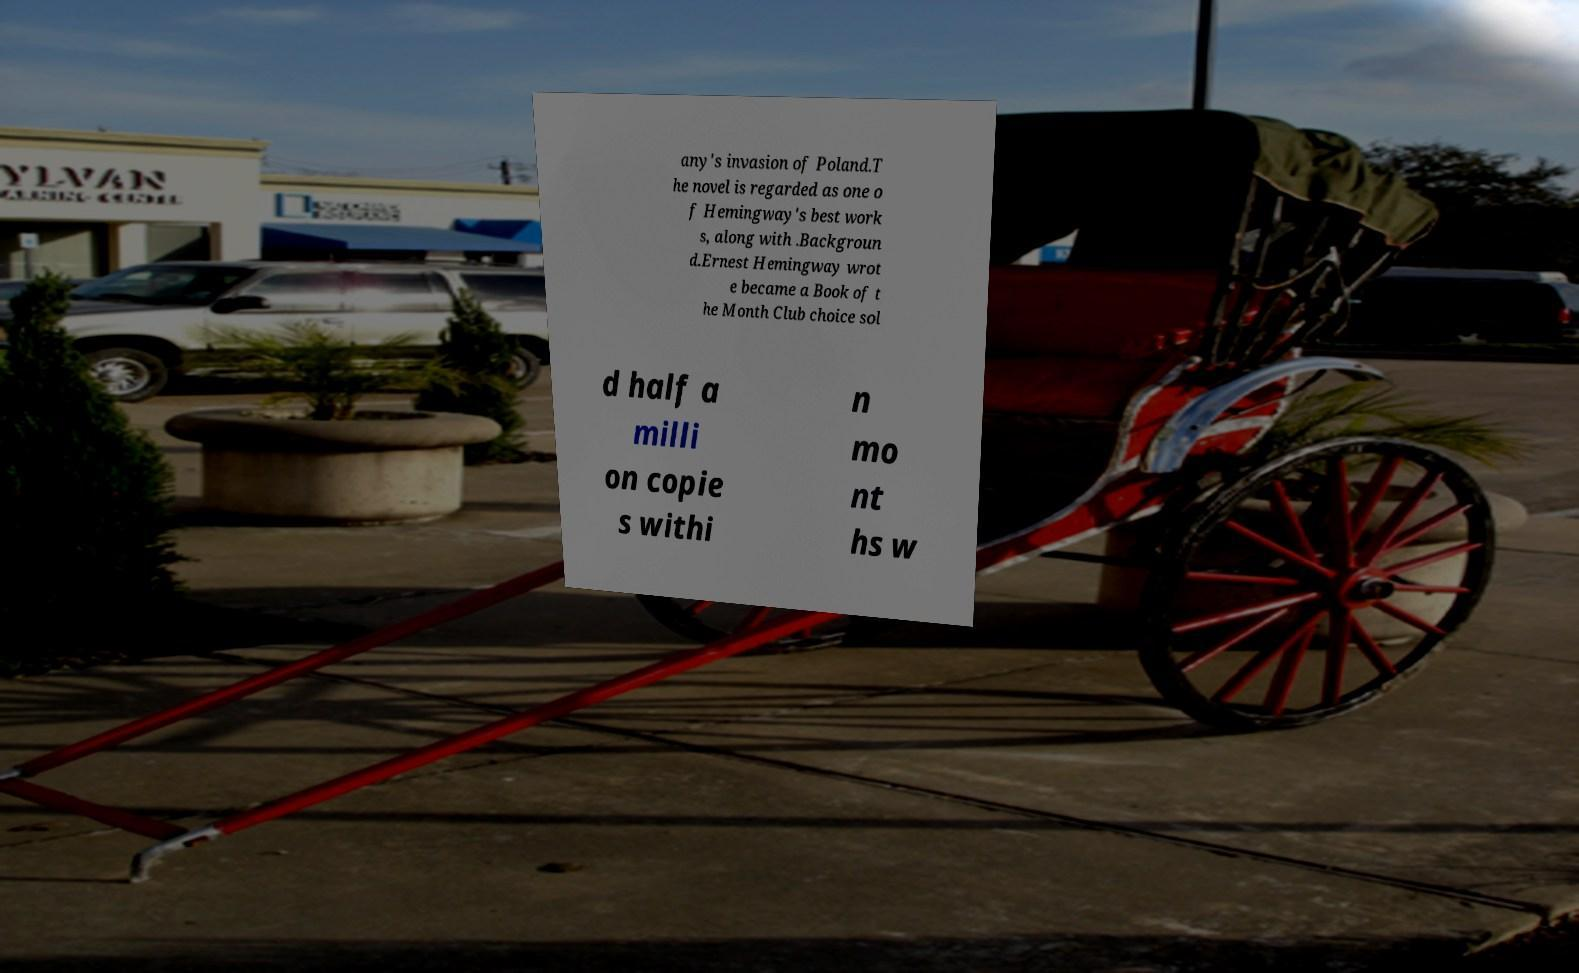Can you read and provide the text displayed in the image?This photo seems to have some interesting text. Can you extract and type it out for me? any's invasion of Poland.T he novel is regarded as one o f Hemingway's best work s, along with .Backgroun d.Ernest Hemingway wrot e became a Book of t he Month Club choice sol d half a milli on copie s withi n mo nt hs w 